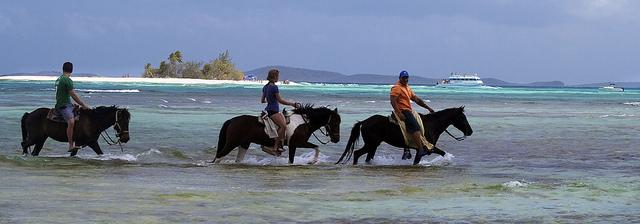What is the terrain with trees on it? island 